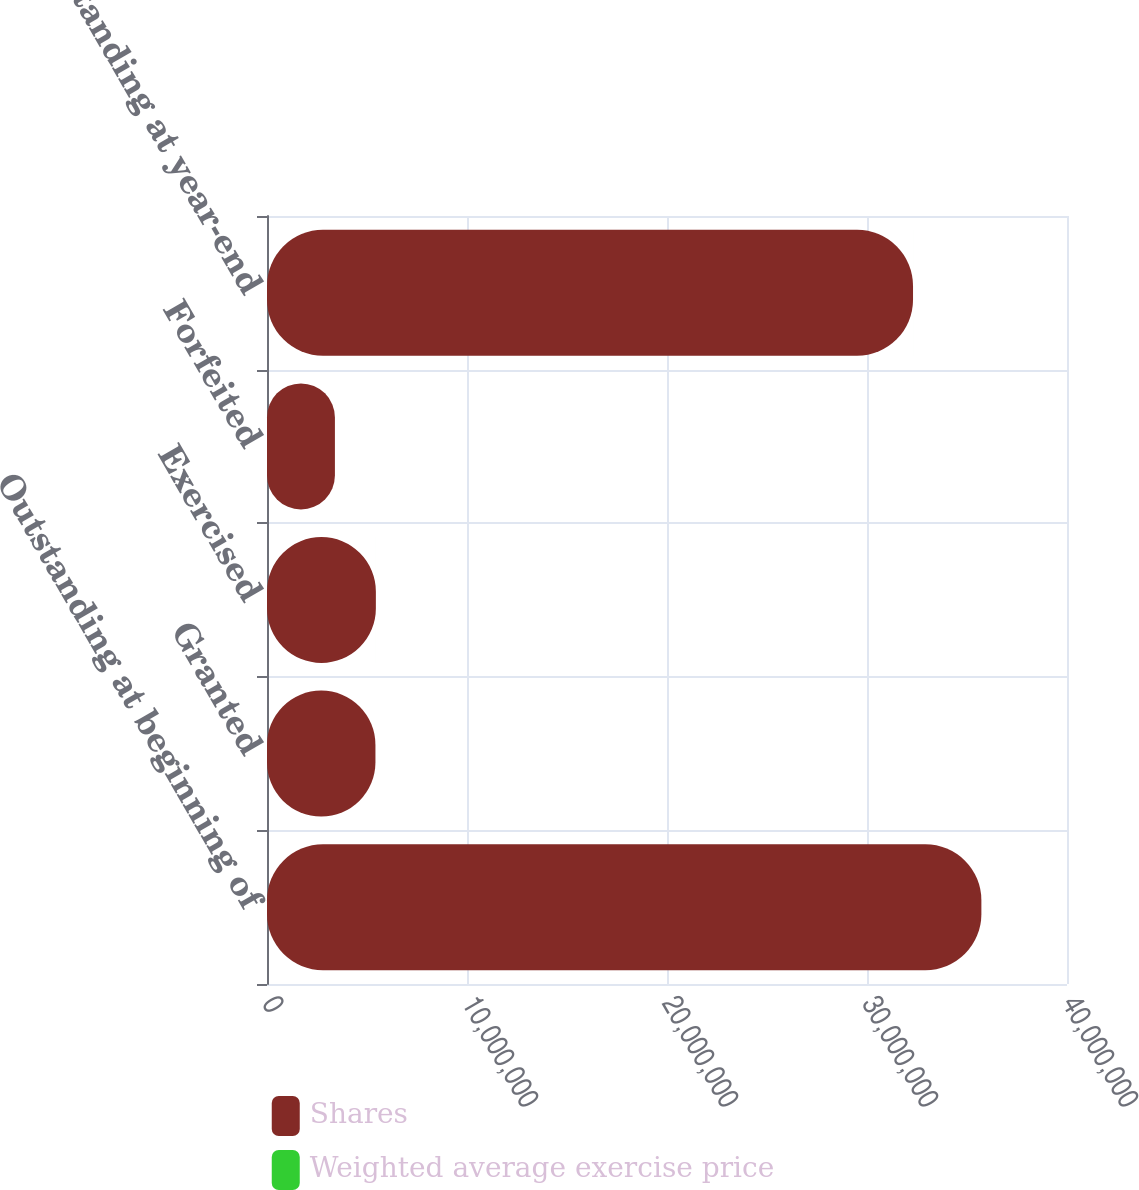Convert chart. <chart><loc_0><loc_0><loc_500><loc_500><stacked_bar_chart><ecel><fcel>Outstanding at beginning of<fcel>Granted<fcel>Exercised<fcel>Forfeited<fcel>Outstanding at year-end<nl><fcel>Shares<fcel>3.57188e+07<fcel>5.4219e+06<fcel>5.44355e+06<fcel>3.39581e+06<fcel>3.23013e+07<nl><fcel>Weighted average exercise price<fcel>41.02<fcel>84.95<fcel>32.69<fcel>42.68<fcel>50.36<nl></chart> 